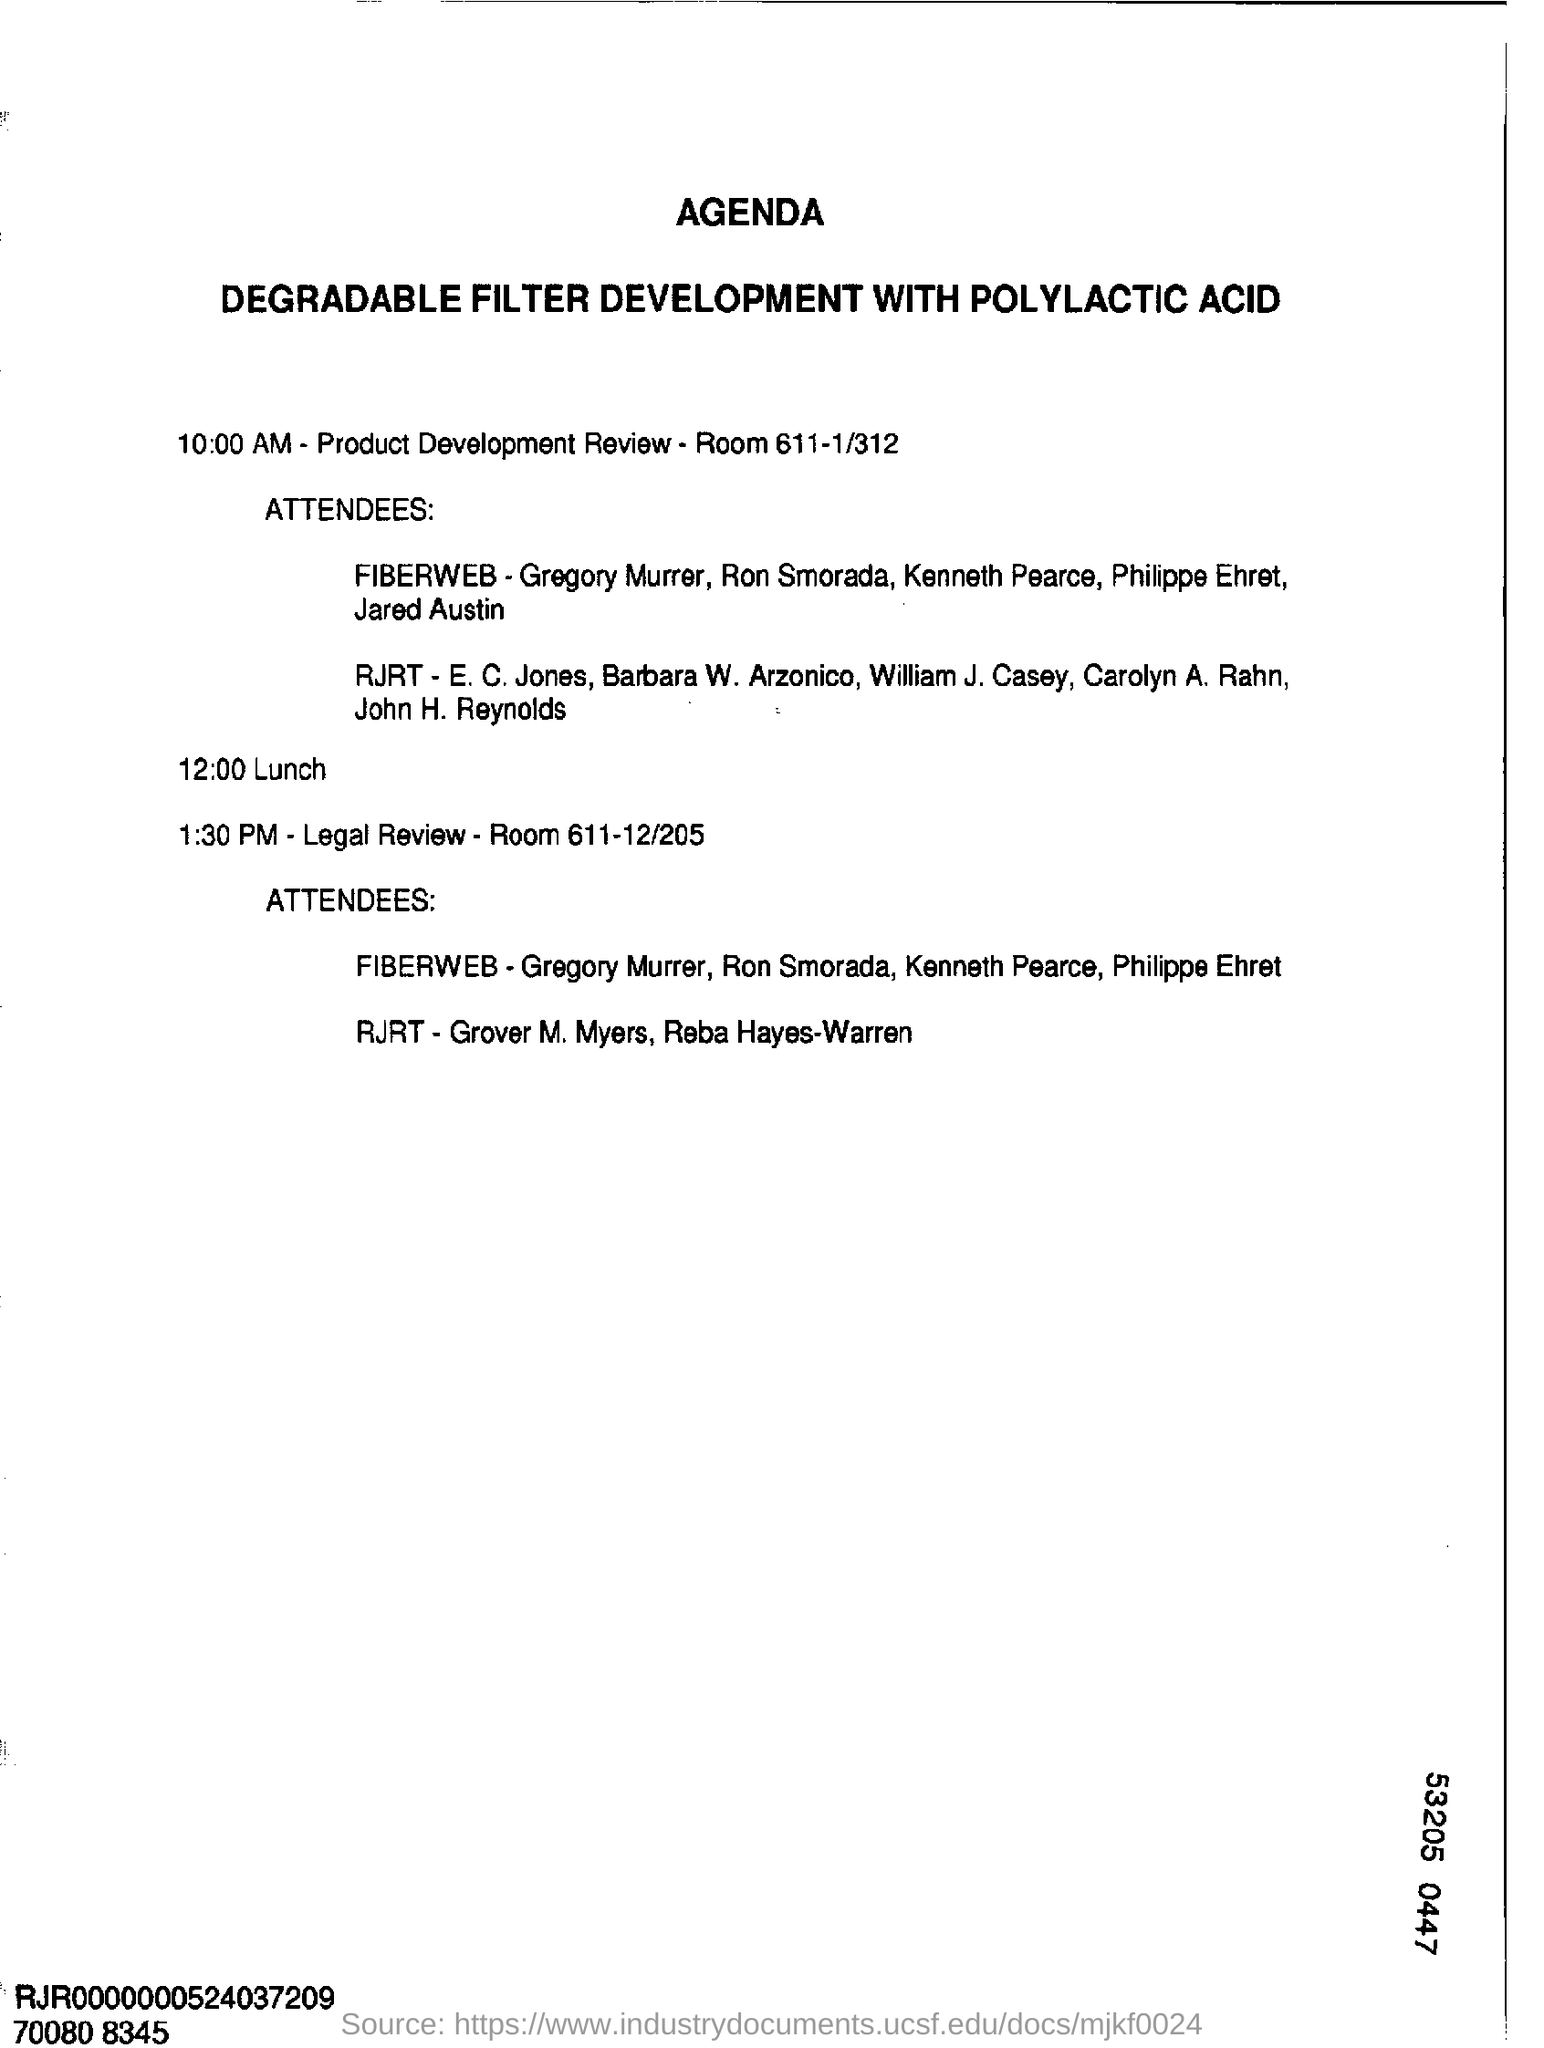Product development review is organised in which room?
Offer a very short reply. 611-1/312. What is the agenda mentioned in the document?
Provide a short and direct response. Degradable Filter Development with Polylactic Acid. What is the program mentioned at 1.30 pm?
Offer a terse response. Legal Review. 